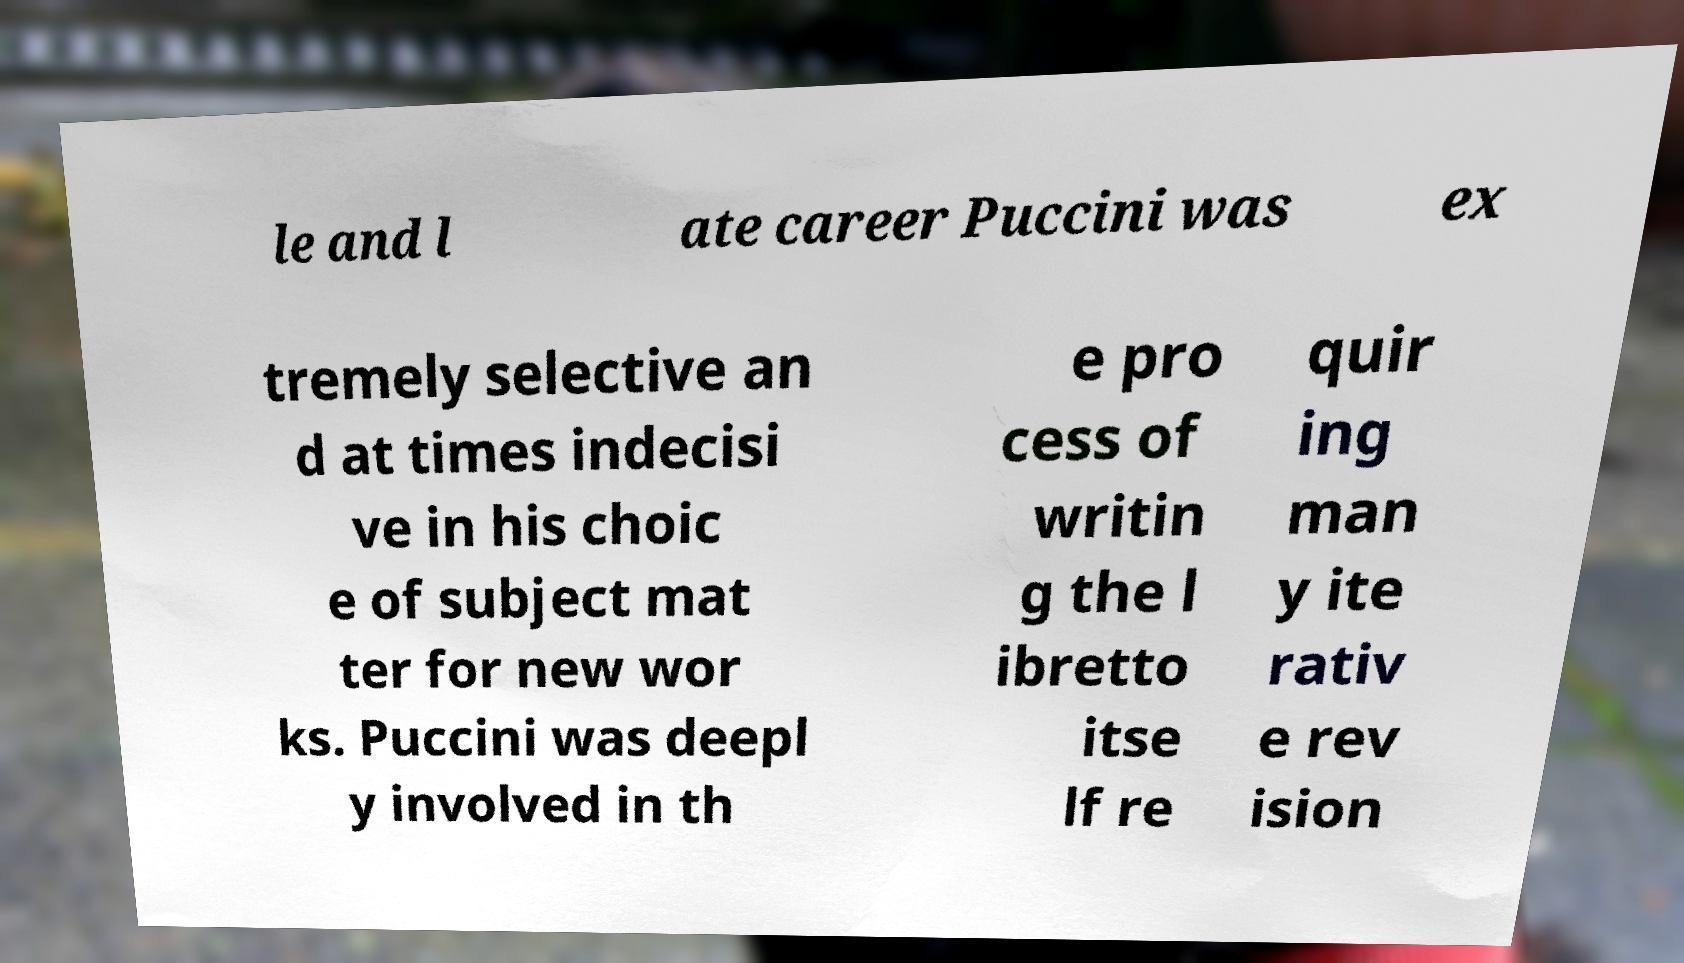Could you extract and type out the text from this image? le and l ate career Puccini was ex tremely selective an d at times indecisi ve in his choic e of subject mat ter for new wor ks. Puccini was deepl y involved in th e pro cess of writin g the l ibretto itse lf re quir ing man y ite rativ e rev ision 